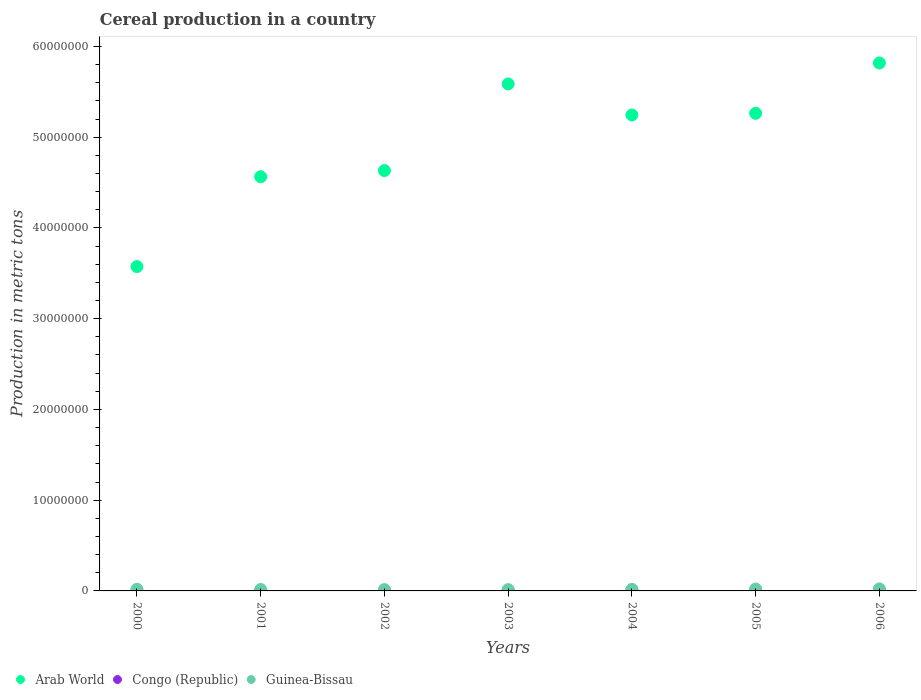Is the number of dotlines equal to the number of legend labels?
Offer a terse response. Yes. What is the total cereal production in Guinea-Bissau in 2001?
Give a very brief answer. 1.62e+05. Across all years, what is the maximum total cereal production in Arab World?
Ensure brevity in your answer.  5.82e+07. Across all years, what is the minimum total cereal production in Guinea-Bissau?
Make the answer very short. 1.43e+05. In which year was the total cereal production in Congo (Republic) maximum?
Your response must be concise. 2004. In which year was the total cereal production in Congo (Republic) minimum?
Keep it short and to the point. 2000. What is the total total cereal production in Arab World in the graph?
Offer a very short reply. 3.47e+08. What is the difference between the total cereal production in Arab World in 2001 and that in 2004?
Provide a short and direct response. -6.81e+06. What is the difference between the total cereal production in Arab World in 2003 and the total cereal production in Guinea-Bissau in 2005?
Keep it short and to the point. 5.57e+07. What is the average total cereal production in Congo (Republic) per year?
Make the answer very short. 1.97e+04. In the year 2005, what is the difference between the total cereal production in Congo (Republic) and total cereal production in Arab World?
Give a very brief answer. -5.26e+07. What is the ratio of the total cereal production in Arab World in 2002 to that in 2003?
Provide a succinct answer. 0.83. What is the difference between the highest and the second highest total cereal production in Congo (Republic)?
Provide a succinct answer. 605. What is the difference between the highest and the lowest total cereal production in Arab World?
Offer a terse response. 2.24e+07. Does the total cereal production in Congo (Republic) monotonically increase over the years?
Provide a succinct answer. No. Is the total cereal production in Guinea-Bissau strictly less than the total cereal production in Congo (Republic) over the years?
Your answer should be compact. No. How many dotlines are there?
Your answer should be compact. 3. What is the difference between two consecutive major ticks on the Y-axis?
Offer a terse response. 1.00e+07. Are the values on the major ticks of Y-axis written in scientific E-notation?
Your answer should be compact. No. Does the graph contain any zero values?
Offer a very short reply. No. Does the graph contain grids?
Ensure brevity in your answer.  No. How are the legend labels stacked?
Your answer should be compact. Horizontal. What is the title of the graph?
Ensure brevity in your answer.  Cereal production in a country. What is the label or title of the X-axis?
Provide a short and direct response. Years. What is the label or title of the Y-axis?
Give a very brief answer. Production in metric tons. What is the Production in metric tons of Arab World in 2000?
Provide a succinct answer. 3.57e+07. What is the Production in metric tons in Congo (Republic) in 2000?
Offer a terse response. 9953. What is the Production in metric tons of Guinea-Bissau in 2000?
Your response must be concise. 1.78e+05. What is the Production in metric tons in Arab World in 2001?
Provide a succinct answer. 4.56e+07. What is the Production in metric tons of Congo (Republic) in 2001?
Keep it short and to the point. 1.83e+04. What is the Production in metric tons in Guinea-Bissau in 2001?
Your response must be concise. 1.62e+05. What is the Production in metric tons in Arab World in 2002?
Your answer should be compact. 4.63e+07. What is the Production in metric tons of Congo (Republic) in 2002?
Provide a succinct answer. 1.85e+04. What is the Production in metric tons of Guinea-Bissau in 2002?
Provide a short and direct response. 1.51e+05. What is the Production in metric tons in Arab World in 2003?
Keep it short and to the point. 5.59e+07. What is the Production in metric tons in Congo (Republic) in 2003?
Provide a succinct answer. 2.32e+04. What is the Production in metric tons in Guinea-Bissau in 2003?
Your response must be concise. 1.43e+05. What is the Production in metric tons in Arab World in 2004?
Offer a terse response. 5.25e+07. What is the Production in metric tons in Congo (Republic) in 2004?
Provide a short and direct response. 2.38e+04. What is the Production in metric tons of Guinea-Bissau in 2004?
Your response must be concise. 1.71e+05. What is the Production in metric tons in Arab World in 2005?
Offer a very short reply. 5.26e+07. What is the Production in metric tons in Congo (Republic) in 2005?
Offer a terse response. 2.23e+04. What is the Production in metric tons of Guinea-Bissau in 2005?
Offer a very short reply. 2.13e+05. What is the Production in metric tons in Arab World in 2006?
Your answer should be very brief. 5.82e+07. What is the Production in metric tons of Congo (Republic) in 2006?
Your answer should be very brief. 2.17e+04. What is the Production in metric tons of Guinea-Bissau in 2006?
Make the answer very short. 2.25e+05. Across all years, what is the maximum Production in metric tons in Arab World?
Your answer should be very brief. 5.82e+07. Across all years, what is the maximum Production in metric tons in Congo (Republic)?
Your answer should be very brief. 2.38e+04. Across all years, what is the maximum Production in metric tons of Guinea-Bissau?
Keep it short and to the point. 2.25e+05. Across all years, what is the minimum Production in metric tons in Arab World?
Provide a short and direct response. 3.57e+07. Across all years, what is the minimum Production in metric tons in Congo (Republic)?
Offer a very short reply. 9953. Across all years, what is the minimum Production in metric tons of Guinea-Bissau?
Give a very brief answer. 1.43e+05. What is the total Production in metric tons of Arab World in the graph?
Provide a short and direct response. 3.47e+08. What is the total Production in metric tons of Congo (Republic) in the graph?
Your answer should be very brief. 1.38e+05. What is the total Production in metric tons of Guinea-Bissau in the graph?
Offer a very short reply. 1.24e+06. What is the difference between the Production in metric tons of Arab World in 2000 and that in 2001?
Ensure brevity in your answer.  -9.90e+06. What is the difference between the Production in metric tons in Congo (Republic) in 2000 and that in 2001?
Offer a very short reply. -8313. What is the difference between the Production in metric tons in Guinea-Bissau in 2000 and that in 2001?
Offer a terse response. 1.62e+04. What is the difference between the Production in metric tons of Arab World in 2000 and that in 2002?
Ensure brevity in your answer.  -1.06e+07. What is the difference between the Production in metric tons of Congo (Republic) in 2000 and that in 2002?
Your response must be concise. -8593. What is the difference between the Production in metric tons of Guinea-Bissau in 2000 and that in 2002?
Ensure brevity in your answer.  2.64e+04. What is the difference between the Production in metric tons in Arab World in 2000 and that in 2003?
Give a very brief answer. -2.01e+07. What is the difference between the Production in metric tons in Congo (Republic) in 2000 and that in 2003?
Your answer should be very brief. -1.32e+04. What is the difference between the Production in metric tons in Guinea-Bissau in 2000 and that in 2003?
Provide a short and direct response. 3.45e+04. What is the difference between the Production in metric tons of Arab World in 2000 and that in 2004?
Provide a succinct answer. -1.67e+07. What is the difference between the Production in metric tons in Congo (Republic) in 2000 and that in 2004?
Offer a terse response. -1.38e+04. What is the difference between the Production in metric tons in Guinea-Bissau in 2000 and that in 2004?
Your response must be concise. 6509. What is the difference between the Production in metric tons of Arab World in 2000 and that in 2005?
Offer a very short reply. -1.69e+07. What is the difference between the Production in metric tons of Congo (Republic) in 2000 and that in 2005?
Offer a terse response. -1.23e+04. What is the difference between the Production in metric tons in Guinea-Bissau in 2000 and that in 2005?
Provide a succinct answer. -3.47e+04. What is the difference between the Production in metric tons of Arab World in 2000 and that in 2006?
Offer a terse response. -2.24e+07. What is the difference between the Production in metric tons of Congo (Republic) in 2000 and that in 2006?
Provide a short and direct response. -1.17e+04. What is the difference between the Production in metric tons of Guinea-Bissau in 2000 and that in 2006?
Provide a succinct answer. -4.74e+04. What is the difference between the Production in metric tons of Arab World in 2001 and that in 2002?
Provide a succinct answer. -6.81e+05. What is the difference between the Production in metric tons in Congo (Republic) in 2001 and that in 2002?
Give a very brief answer. -280. What is the difference between the Production in metric tons of Guinea-Bissau in 2001 and that in 2002?
Your response must be concise. 1.02e+04. What is the difference between the Production in metric tons in Arab World in 2001 and that in 2003?
Keep it short and to the point. -1.02e+07. What is the difference between the Production in metric tons in Congo (Republic) in 2001 and that in 2003?
Provide a succinct answer. -4884. What is the difference between the Production in metric tons of Guinea-Bissau in 2001 and that in 2003?
Keep it short and to the point. 1.83e+04. What is the difference between the Production in metric tons of Arab World in 2001 and that in 2004?
Make the answer very short. -6.81e+06. What is the difference between the Production in metric tons in Congo (Republic) in 2001 and that in 2004?
Offer a very short reply. -5489. What is the difference between the Production in metric tons in Guinea-Bissau in 2001 and that in 2004?
Offer a terse response. -9694. What is the difference between the Production in metric tons in Arab World in 2001 and that in 2005?
Keep it short and to the point. -6.99e+06. What is the difference between the Production in metric tons of Congo (Republic) in 2001 and that in 2005?
Provide a succinct answer. -4031. What is the difference between the Production in metric tons in Guinea-Bissau in 2001 and that in 2005?
Your response must be concise. -5.09e+04. What is the difference between the Production in metric tons of Arab World in 2001 and that in 2006?
Your answer should be compact. -1.25e+07. What is the difference between the Production in metric tons in Congo (Republic) in 2001 and that in 2006?
Give a very brief answer. -3434. What is the difference between the Production in metric tons in Guinea-Bissau in 2001 and that in 2006?
Offer a very short reply. -6.36e+04. What is the difference between the Production in metric tons in Arab World in 2002 and that in 2003?
Offer a terse response. -9.55e+06. What is the difference between the Production in metric tons in Congo (Republic) in 2002 and that in 2003?
Keep it short and to the point. -4604. What is the difference between the Production in metric tons in Guinea-Bissau in 2002 and that in 2003?
Provide a short and direct response. 8033. What is the difference between the Production in metric tons of Arab World in 2002 and that in 2004?
Make the answer very short. -6.13e+06. What is the difference between the Production in metric tons in Congo (Republic) in 2002 and that in 2004?
Your answer should be very brief. -5209. What is the difference between the Production in metric tons of Guinea-Bissau in 2002 and that in 2004?
Your response must be concise. -1.99e+04. What is the difference between the Production in metric tons of Arab World in 2002 and that in 2005?
Ensure brevity in your answer.  -6.31e+06. What is the difference between the Production in metric tons of Congo (Republic) in 2002 and that in 2005?
Your answer should be very brief. -3751. What is the difference between the Production in metric tons of Guinea-Bissau in 2002 and that in 2005?
Offer a very short reply. -6.11e+04. What is the difference between the Production in metric tons in Arab World in 2002 and that in 2006?
Provide a short and direct response. -1.19e+07. What is the difference between the Production in metric tons of Congo (Republic) in 2002 and that in 2006?
Ensure brevity in your answer.  -3154. What is the difference between the Production in metric tons in Guinea-Bissau in 2002 and that in 2006?
Your answer should be very brief. -7.38e+04. What is the difference between the Production in metric tons in Arab World in 2003 and that in 2004?
Your answer should be very brief. 3.42e+06. What is the difference between the Production in metric tons of Congo (Republic) in 2003 and that in 2004?
Your response must be concise. -605. What is the difference between the Production in metric tons of Guinea-Bissau in 2003 and that in 2004?
Ensure brevity in your answer.  -2.80e+04. What is the difference between the Production in metric tons of Arab World in 2003 and that in 2005?
Offer a very short reply. 3.24e+06. What is the difference between the Production in metric tons in Congo (Republic) in 2003 and that in 2005?
Ensure brevity in your answer.  853. What is the difference between the Production in metric tons in Guinea-Bissau in 2003 and that in 2005?
Provide a succinct answer. -6.91e+04. What is the difference between the Production in metric tons in Arab World in 2003 and that in 2006?
Offer a very short reply. -2.31e+06. What is the difference between the Production in metric tons of Congo (Republic) in 2003 and that in 2006?
Your answer should be very brief. 1450. What is the difference between the Production in metric tons of Guinea-Bissau in 2003 and that in 2006?
Keep it short and to the point. -8.18e+04. What is the difference between the Production in metric tons of Arab World in 2004 and that in 2005?
Offer a very short reply. -1.83e+05. What is the difference between the Production in metric tons in Congo (Republic) in 2004 and that in 2005?
Make the answer very short. 1458. What is the difference between the Production in metric tons in Guinea-Bissau in 2004 and that in 2005?
Give a very brief answer. -4.12e+04. What is the difference between the Production in metric tons in Arab World in 2004 and that in 2006?
Provide a succinct answer. -5.73e+06. What is the difference between the Production in metric tons in Congo (Republic) in 2004 and that in 2006?
Ensure brevity in your answer.  2055. What is the difference between the Production in metric tons of Guinea-Bissau in 2004 and that in 2006?
Keep it short and to the point. -5.39e+04. What is the difference between the Production in metric tons of Arab World in 2005 and that in 2006?
Give a very brief answer. -5.55e+06. What is the difference between the Production in metric tons in Congo (Republic) in 2005 and that in 2006?
Your response must be concise. 597. What is the difference between the Production in metric tons in Guinea-Bissau in 2005 and that in 2006?
Your answer should be very brief. -1.27e+04. What is the difference between the Production in metric tons in Arab World in 2000 and the Production in metric tons in Congo (Republic) in 2001?
Provide a succinct answer. 3.57e+07. What is the difference between the Production in metric tons in Arab World in 2000 and the Production in metric tons in Guinea-Bissau in 2001?
Make the answer very short. 3.56e+07. What is the difference between the Production in metric tons of Congo (Republic) in 2000 and the Production in metric tons of Guinea-Bissau in 2001?
Give a very brief answer. -1.52e+05. What is the difference between the Production in metric tons of Arab World in 2000 and the Production in metric tons of Congo (Republic) in 2002?
Your answer should be very brief. 3.57e+07. What is the difference between the Production in metric tons in Arab World in 2000 and the Production in metric tons in Guinea-Bissau in 2002?
Your answer should be compact. 3.56e+07. What is the difference between the Production in metric tons of Congo (Republic) in 2000 and the Production in metric tons of Guinea-Bissau in 2002?
Offer a very short reply. -1.41e+05. What is the difference between the Production in metric tons in Arab World in 2000 and the Production in metric tons in Congo (Republic) in 2003?
Your answer should be very brief. 3.57e+07. What is the difference between the Production in metric tons in Arab World in 2000 and the Production in metric tons in Guinea-Bissau in 2003?
Ensure brevity in your answer.  3.56e+07. What is the difference between the Production in metric tons of Congo (Republic) in 2000 and the Production in metric tons of Guinea-Bissau in 2003?
Keep it short and to the point. -1.33e+05. What is the difference between the Production in metric tons of Arab World in 2000 and the Production in metric tons of Congo (Republic) in 2004?
Ensure brevity in your answer.  3.57e+07. What is the difference between the Production in metric tons of Arab World in 2000 and the Production in metric tons of Guinea-Bissau in 2004?
Ensure brevity in your answer.  3.56e+07. What is the difference between the Production in metric tons in Congo (Republic) in 2000 and the Production in metric tons in Guinea-Bissau in 2004?
Keep it short and to the point. -1.61e+05. What is the difference between the Production in metric tons of Arab World in 2000 and the Production in metric tons of Congo (Republic) in 2005?
Give a very brief answer. 3.57e+07. What is the difference between the Production in metric tons of Arab World in 2000 and the Production in metric tons of Guinea-Bissau in 2005?
Give a very brief answer. 3.55e+07. What is the difference between the Production in metric tons in Congo (Republic) in 2000 and the Production in metric tons in Guinea-Bissau in 2005?
Your answer should be compact. -2.03e+05. What is the difference between the Production in metric tons of Arab World in 2000 and the Production in metric tons of Congo (Republic) in 2006?
Ensure brevity in your answer.  3.57e+07. What is the difference between the Production in metric tons of Arab World in 2000 and the Production in metric tons of Guinea-Bissau in 2006?
Your response must be concise. 3.55e+07. What is the difference between the Production in metric tons in Congo (Republic) in 2000 and the Production in metric tons in Guinea-Bissau in 2006?
Ensure brevity in your answer.  -2.15e+05. What is the difference between the Production in metric tons of Arab World in 2001 and the Production in metric tons of Congo (Republic) in 2002?
Ensure brevity in your answer.  4.56e+07. What is the difference between the Production in metric tons in Arab World in 2001 and the Production in metric tons in Guinea-Bissau in 2002?
Provide a succinct answer. 4.55e+07. What is the difference between the Production in metric tons in Congo (Republic) in 2001 and the Production in metric tons in Guinea-Bissau in 2002?
Provide a succinct answer. -1.33e+05. What is the difference between the Production in metric tons in Arab World in 2001 and the Production in metric tons in Congo (Republic) in 2003?
Your answer should be compact. 4.56e+07. What is the difference between the Production in metric tons in Arab World in 2001 and the Production in metric tons in Guinea-Bissau in 2003?
Your answer should be very brief. 4.55e+07. What is the difference between the Production in metric tons of Congo (Republic) in 2001 and the Production in metric tons of Guinea-Bissau in 2003?
Ensure brevity in your answer.  -1.25e+05. What is the difference between the Production in metric tons in Arab World in 2001 and the Production in metric tons in Congo (Republic) in 2004?
Provide a succinct answer. 4.56e+07. What is the difference between the Production in metric tons of Arab World in 2001 and the Production in metric tons of Guinea-Bissau in 2004?
Provide a succinct answer. 4.55e+07. What is the difference between the Production in metric tons of Congo (Republic) in 2001 and the Production in metric tons of Guinea-Bissau in 2004?
Your answer should be very brief. -1.53e+05. What is the difference between the Production in metric tons in Arab World in 2001 and the Production in metric tons in Congo (Republic) in 2005?
Ensure brevity in your answer.  4.56e+07. What is the difference between the Production in metric tons of Arab World in 2001 and the Production in metric tons of Guinea-Bissau in 2005?
Offer a terse response. 4.54e+07. What is the difference between the Production in metric tons of Congo (Republic) in 2001 and the Production in metric tons of Guinea-Bissau in 2005?
Give a very brief answer. -1.94e+05. What is the difference between the Production in metric tons of Arab World in 2001 and the Production in metric tons of Congo (Republic) in 2006?
Ensure brevity in your answer.  4.56e+07. What is the difference between the Production in metric tons in Arab World in 2001 and the Production in metric tons in Guinea-Bissau in 2006?
Your answer should be very brief. 4.54e+07. What is the difference between the Production in metric tons of Congo (Republic) in 2001 and the Production in metric tons of Guinea-Bissau in 2006?
Your answer should be compact. -2.07e+05. What is the difference between the Production in metric tons of Arab World in 2002 and the Production in metric tons of Congo (Republic) in 2003?
Ensure brevity in your answer.  4.63e+07. What is the difference between the Production in metric tons of Arab World in 2002 and the Production in metric tons of Guinea-Bissau in 2003?
Offer a very short reply. 4.62e+07. What is the difference between the Production in metric tons of Congo (Republic) in 2002 and the Production in metric tons of Guinea-Bissau in 2003?
Offer a terse response. -1.25e+05. What is the difference between the Production in metric tons in Arab World in 2002 and the Production in metric tons in Congo (Republic) in 2004?
Provide a short and direct response. 4.63e+07. What is the difference between the Production in metric tons in Arab World in 2002 and the Production in metric tons in Guinea-Bissau in 2004?
Ensure brevity in your answer.  4.62e+07. What is the difference between the Production in metric tons in Congo (Republic) in 2002 and the Production in metric tons in Guinea-Bissau in 2004?
Give a very brief answer. -1.53e+05. What is the difference between the Production in metric tons of Arab World in 2002 and the Production in metric tons of Congo (Republic) in 2005?
Provide a short and direct response. 4.63e+07. What is the difference between the Production in metric tons in Arab World in 2002 and the Production in metric tons in Guinea-Bissau in 2005?
Make the answer very short. 4.61e+07. What is the difference between the Production in metric tons of Congo (Republic) in 2002 and the Production in metric tons of Guinea-Bissau in 2005?
Your response must be concise. -1.94e+05. What is the difference between the Production in metric tons in Arab World in 2002 and the Production in metric tons in Congo (Republic) in 2006?
Keep it short and to the point. 4.63e+07. What is the difference between the Production in metric tons in Arab World in 2002 and the Production in metric tons in Guinea-Bissau in 2006?
Provide a short and direct response. 4.61e+07. What is the difference between the Production in metric tons of Congo (Republic) in 2002 and the Production in metric tons of Guinea-Bissau in 2006?
Provide a short and direct response. -2.07e+05. What is the difference between the Production in metric tons in Arab World in 2003 and the Production in metric tons in Congo (Republic) in 2004?
Ensure brevity in your answer.  5.58e+07. What is the difference between the Production in metric tons in Arab World in 2003 and the Production in metric tons in Guinea-Bissau in 2004?
Your response must be concise. 5.57e+07. What is the difference between the Production in metric tons of Congo (Republic) in 2003 and the Production in metric tons of Guinea-Bissau in 2004?
Offer a very short reply. -1.48e+05. What is the difference between the Production in metric tons in Arab World in 2003 and the Production in metric tons in Congo (Republic) in 2005?
Provide a succinct answer. 5.58e+07. What is the difference between the Production in metric tons in Arab World in 2003 and the Production in metric tons in Guinea-Bissau in 2005?
Provide a short and direct response. 5.57e+07. What is the difference between the Production in metric tons of Congo (Republic) in 2003 and the Production in metric tons of Guinea-Bissau in 2005?
Provide a succinct answer. -1.89e+05. What is the difference between the Production in metric tons of Arab World in 2003 and the Production in metric tons of Congo (Republic) in 2006?
Ensure brevity in your answer.  5.58e+07. What is the difference between the Production in metric tons of Arab World in 2003 and the Production in metric tons of Guinea-Bissau in 2006?
Provide a succinct answer. 5.56e+07. What is the difference between the Production in metric tons in Congo (Republic) in 2003 and the Production in metric tons in Guinea-Bissau in 2006?
Ensure brevity in your answer.  -2.02e+05. What is the difference between the Production in metric tons of Arab World in 2004 and the Production in metric tons of Congo (Republic) in 2005?
Your response must be concise. 5.24e+07. What is the difference between the Production in metric tons in Arab World in 2004 and the Production in metric tons in Guinea-Bissau in 2005?
Your answer should be very brief. 5.22e+07. What is the difference between the Production in metric tons of Congo (Republic) in 2004 and the Production in metric tons of Guinea-Bissau in 2005?
Your answer should be compact. -1.89e+05. What is the difference between the Production in metric tons in Arab World in 2004 and the Production in metric tons in Congo (Republic) in 2006?
Give a very brief answer. 5.24e+07. What is the difference between the Production in metric tons in Arab World in 2004 and the Production in metric tons in Guinea-Bissau in 2006?
Your answer should be compact. 5.22e+07. What is the difference between the Production in metric tons in Congo (Republic) in 2004 and the Production in metric tons in Guinea-Bissau in 2006?
Make the answer very short. -2.02e+05. What is the difference between the Production in metric tons in Arab World in 2005 and the Production in metric tons in Congo (Republic) in 2006?
Make the answer very short. 5.26e+07. What is the difference between the Production in metric tons in Arab World in 2005 and the Production in metric tons in Guinea-Bissau in 2006?
Offer a terse response. 5.24e+07. What is the difference between the Production in metric tons in Congo (Republic) in 2005 and the Production in metric tons in Guinea-Bissau in 2006?
Provide a succinct answer. -2.03e+05. What is the average Production in metric tons of Arab World per year?
Your answer should be compact. 4.95e+07. What is the average Production in metric tons of Congo (Republic) per year?
Keep it short and to the point. 1.97e+04. What is the average Production in metric tons of Guinea-Bissau per year?
Your response must be concise. 1.78e+05. In the year 2000, what is the difference between the Production in metric tons in Arab World and Production in metric tons in Congo (Republic)?
Offer a very short reply. 3.57e+07. In the year 2000, what is the difference between the Production in metric tons of Arab World and Production in metric tons of Guinea-Bissau?
Make the answer very short. 3.56e+07. In the year 2000, what is the difference between the Production in metric tons of Congo (Republic) and Production in metric tons of Guinea-Bissau?
Your response must be concise. -1.68e+05. In the year 2001, what is the difference between the Production in metric tons in Arab World and Production in metric tons in Congo (Republic)?
Offer a very short reply. 4.56e+07. In the year 2001, what is the difference between the Production in metric tons of Arab World and Production in metric tons of Guinea-Bissau?
Your answer should be very brief. 4.55e+07. In the year 2001, what is the difference between the Production in metric tons of Congo (Republic) and Production in metric tons of Guinea-Bissau?
Ensure brevity in your answer.  -1.43e+05. In the year 2002, what is the difference between the Production in metric tons in Arab World and Production in metric tons in Congo (Republic)?
Your answer should be compact. 4.63e+07. In the year 2002, what is the difference between the Production in metric tons in Arab World and Production in metric tons in Guinea-Bissau?
Make the answer very short. 4.62e+07. In the year 2002, what is the difference between the Production in metric tons in Congo (Republic) and Production in metric tons in Guinea-Bissau?
Ensure brevity in your answer.  -1.33e+05. In the year 2003, what is the difference between the Production in metric tons of Arab World and Production in metric tons of Congo (Republic)?
Provide a succinct answer. 5.58e+07. In the year 2003, what is the difference between the Production in metric tons of Arab World and Production in metric tons of Guinea-Bissau?
Give a very brief answer. 5.57e+07. In the year 2003, what is the difference between the Production in metric tons in Congo (Republic) and Production in metric tons in Guinea-Bissau?
Your answer should be compact. -1.20e+05. In the year 2004, what is the difference between the Production in metric tons in Arab World and Production in metric tons in Congo (Republic)?
Your response must be concise. 5.24e+07. In the year 2004, what is the difference between the Production in metric tons of Arab World and Production in metric tons of Guinea-Bissau?
Keep it short and to the point. 5.23e+07. In the year 2004, what is the difference between the Production in metric tons in Congo (Republic) and Production in metric tons in Guinea-Bissau?
Provide a short and direct response. -1.48e+05. In the year 2005, what is the difference between the Production in metric tons in Arab World and Production in metric tons in Congo (Republic)?
Offer a very short reply. 5.26e+07. In the year 2005, what is the difference between the Production in metric tons in Arab World and Production in metric tons in Guinea-Bissau?
Your response must be concise. 5.24e+07. In the year 2005, what is the difference between the Production in metric tons of Congo (Republic) and Production in metric tons of Guinea-Bissau?
Offer a very short reply. -1.90e+05. In the year 2006, what is the difference between the Production in metric tons in Arab World and Production in metric tons in Congo (Republic)?
Provide a short and direct response. 5.82e+07. In the year 2006, what is the difference between the Production in metric tons of Arab World and Production in metric tons of Guinea-Bissau?
Your answer should be compact. 5.80e+07. In the year 2006, what is the difference between the Production in metric tons of Congo (Republic) and Production in metric tons of Guinea-Bissau?
Provide a succinct answer. -2.04e+05. What is the ratio of the Production in metric tons of Arab World in 2000 to that in 2001?
Keep it short and to the point. 0.78. What is the ratio of the Production in metric tons of Congo (Republic) in 2000 to that in 2001?
Offer a very short reply. 0.54. What is the ratio of the Production in metric tons of Guinea-Bissau in 2000 to that in 2001?
Provide a short and direct response. 1.1. What is the ratio of the Production in metric tons in Arab World in 2000 to that in 2002?
Provide a short and direct response. 0.77. What is the ratio of the Production in metric tons in Congo (Republic) in 2000 to that in 2002?
Provide a short and direct response. 0.54. What is the ratio of the Production in metric tons of Guinea-Bissau in 2000 to that in 2002?
Provide a short and direct response. 1.17. What is the ratio of the Production in metric tons of Arab World in 2000 to that in 2003?
Your answer should be very brief. 0.64. What is the ratio of the Production in metric tons of Congo (Republic) in 2000 to that in 2003?
Ensure brevity in your answer.  0.43. What is the ratio of the Production in metric tons in Guinea-Bissau in 2000 to that in 2003?
Offer a terse response. 1.24. What is the ratio of the Production in metric tons in Arab World in 2000 to that in 2004?
Keep it short and to the point. 0.68. What is the ratio of the Production in metric tons in Congo (Republic) in 2000 to that in 2004?
Your response must be concise. 0.42. What is the ratio of the Production in metric tons in Guinea-Bissau in 2000 to that in 2004?
Give a very brief answer. 1.04. What is the ratio of the Production in metric tons of Arab World in 2000 to that in 2005?
Offer a very short reply. 0.68. What is the ratio of the Production in metric tons of Congo (Republic) in 2000 to that in 2005?
Your response must be concise. 0.45. What is the ratio of the Production in metric tons in Guinea-Bissau in 2000 to that in 2005?
Provide a short and direct response. 0.84. What is the ratio of the Production in metric tons in Arab World in 2000 to that in 2006?
Keep it short and to the point. 0.61. What is the ratio of the Production in metric tons of Congo (Republic) in 2000 to that in 2006?
Provide a short and direct response. 0.46. What is the ratio of the Production in metric tons in Guinea-Bissau in 2000 to that in 2006?
Offer a very short reply. 0.79. What is the ratio of the Production in metric tons in Congo (Republic) in 2001 to that in 2002?
Offer a terse response. 0.98. What is the ratio of the Production in metric tons of Guinea-Bissau in 2001 to that in 2002?
Ensure brevity in your answer.  1.07. What is the ratio of the Production in metric tons of Arab World in 2001 to that in 2003?
Keep it short and to the point. 0.82. What is the ratio of the Production in metric tons in Congo (Republic) in 2001 to that in 2003?
Give a very brief answer. 0.79. What is the ratio of the Production in metric tons of Guinea-Bissau in 2001 to that in 2003?
Give a very brief answer. 1.13. What is the ratio of the Production in metric tons of Arab World in 2001 to that in 2004?
Ensure brevity in your answer.  0.87. What is the ratio of the Production in metric tons of Congo (Republic) in 2001 to that in 2004?
Offer a very short reply. 0.77. What is the ratio of the Production in metric tons in Guinea-Bissau in 2001 to that in 2004?
Ensure brevity in your answer.  0.94. What is the ratio of the Production in metric tons of Arab World in 2001 to that in 2005?
Give a very brief answer. 0.87. What is the ratio of the Production in metric tons in Congo (Republic) in 2001 to that in 2005?
Ensure brevity in your answer.  0.82. What is the ratio of the Production in metric tons of Guinea-Bissau in 2001 to that in 2005?
Make the answer very short. 0.76. What is the ratio of the Production in metric tons of Arab World in 2001 to that in 2006?
Provide a succinct answer. 0.78. What is the ratio of the Production in metric tons of Congo (Republic) in 2001 to that in 2006?
Offer a terse response. 0.84. What is the ratio of the Production in metric tons of Guinea-Bissau in 2001 to that in 2006?
Ensure brevity in your answer.  0.72. What is the ratio of the Production in metric tons in Arab World in 2002 to that in 2003?
Your answer should be very brief. 0.83. What is the ratio of the Production in metric tons of Congo (Republic) in 2002 to that in 2003?
Keep it short and to the point. 0.8. What is the ratio of the Production in metric tons in Guinea-Bissau in 2002 to that in 2003?
Provide a short and direct response. 1.06. What is the ratio of the Production in metric tons in Arab World in 2002 to that in 2004?
Your answer should be compact. 0.88. What is the ratio of the Production in metric tons of Congo (Republic) in 2002 to that in 2004?
Make the answer very short. 0.78. What is the ratio of the Production in metric tons of Guinea-Bissau in 2002 to that in 2004?
Give a very brief answer. 0.88. What is the ratio of the Production in metric tons of Arab World in 2002 to that in 2005?
Your answer should be very brief. 0.88. What is the ratio of the Production in metric tons of Congo (Republic) in 2002 to that in 2005?
Your answer should be very brief. 0.83. What is the ratio of the Production in metric tons of Guinea-Bissau in 2002 to that in 2005?
Ensure brevity in your answer.  0.71. What is the ratio of the Production in metric tons in Arab World in 2002 to that in 2006?
Make the answer very short. 0.8. What is the ratio of the Production in metric tons of Congo (Republic) in 2002 to that in 2006?
Offer a very short reply. 0.85. What is the ratio of the Production in metric tons of Guinea-Bissau in 2002 to that in 2006?
Give a very brief answer. 0.67. What is the ratio of the Production in metric tons of Arab World in 2003 to that in 2004?
Provide a short and direct response. 1.07. What is the ratio of the Production in metric tons of Congo (Republic) in 2003 to that in 2004?
Your answer should be very brief. 0.97. What is the ratio of the Production in metric tons in Guinea-Bissau in 2003 to that in 2004?
Offer a terse response. 0.84. What is the ratio of the Production in metric tons in Arab World in 2003 to that in 2005?
Ensure brevity in your answer.  1.06. What is the ratio of the Production in metric tons in Congo (Republic) in 2003 to that in 2005?
Provide a succinct answer. 1.04. What is the ratio of the Production in metric tons of Guinea-Bissau in 2003 to that in 2005?
Your response must be concise. 0.67. What is the ratio of the Production in metric tons in Arab World in 2003 to that in 2006?
Make the answer very short. 0.96. What is the ratio of the Production in metric tons of Congo (Republic) in 2003 to that in 2006?
Your answer should be very brief. 1.07. What is the ratio of the Production in metric tons in Guinea-Bissau in 2003 to that in 2006?
Ensure brevity in your answer.  0.64. What is the ratio of the Production in metric tons of Congo (Republic) in 2004 to that in 2005?
Give a very brief answer. 1.07. What is the ratio of the Production in metric tons in Guinea-Bissau in 2004 to that in 2005?
Keep it short and to the point. 0.81. What is the ratio of the Production in metric tons in Arab World in 2004 to that in 2006?
Your answer should be compact. 0.9. What is the ratio of the Production in metric tons of Congo (Republic) in 2004 to that in 2006?
Make the answer very short. 1.09. What is the ratio of the Production in metric tons of Guinea-Bissau in 2004 to that in 2006?
Your answer should be very brief. 0.76. What is the ratio of the Production in metric tons in Arab World in 2005 to that in 2006?
Offer a terse response. 0.9. What is the ratio of the Production in metric tons in Congo (Republic) in 2005 to that in 2006?
Offer a very short reply. 1.03. What is the ratio of the Production in metric tons of Guinea-Bissau in 2005 to that in 2006?
Offer a terse response. 0.94. What is the difference between the highest and the second highest Production in metric tons in Arab World?
Offer a very short reply. 2.31e+06. What is the difference between the highest and the second highest Production in metric tons in Congo (Republic)?
Your answer should be compact. 605. What is the difference between the highest and the second highest Production in metric tons in Guinea-Bissau?
Your response must be concise. 1.27e+04. What is the difference between the highest and the lowest Production in metric tons of Arab World?
Keep it short and to the point. 2.24e+07. What is the difference between the highest and the lowest Production in metric tons in Congo (Republic)?
Make the answer very short. 1.38e+04. What is the difference between the highest and the lowest Production in metric tons in Guinea-Bissau?
Your answer should be very brief. 8.18e+04. 